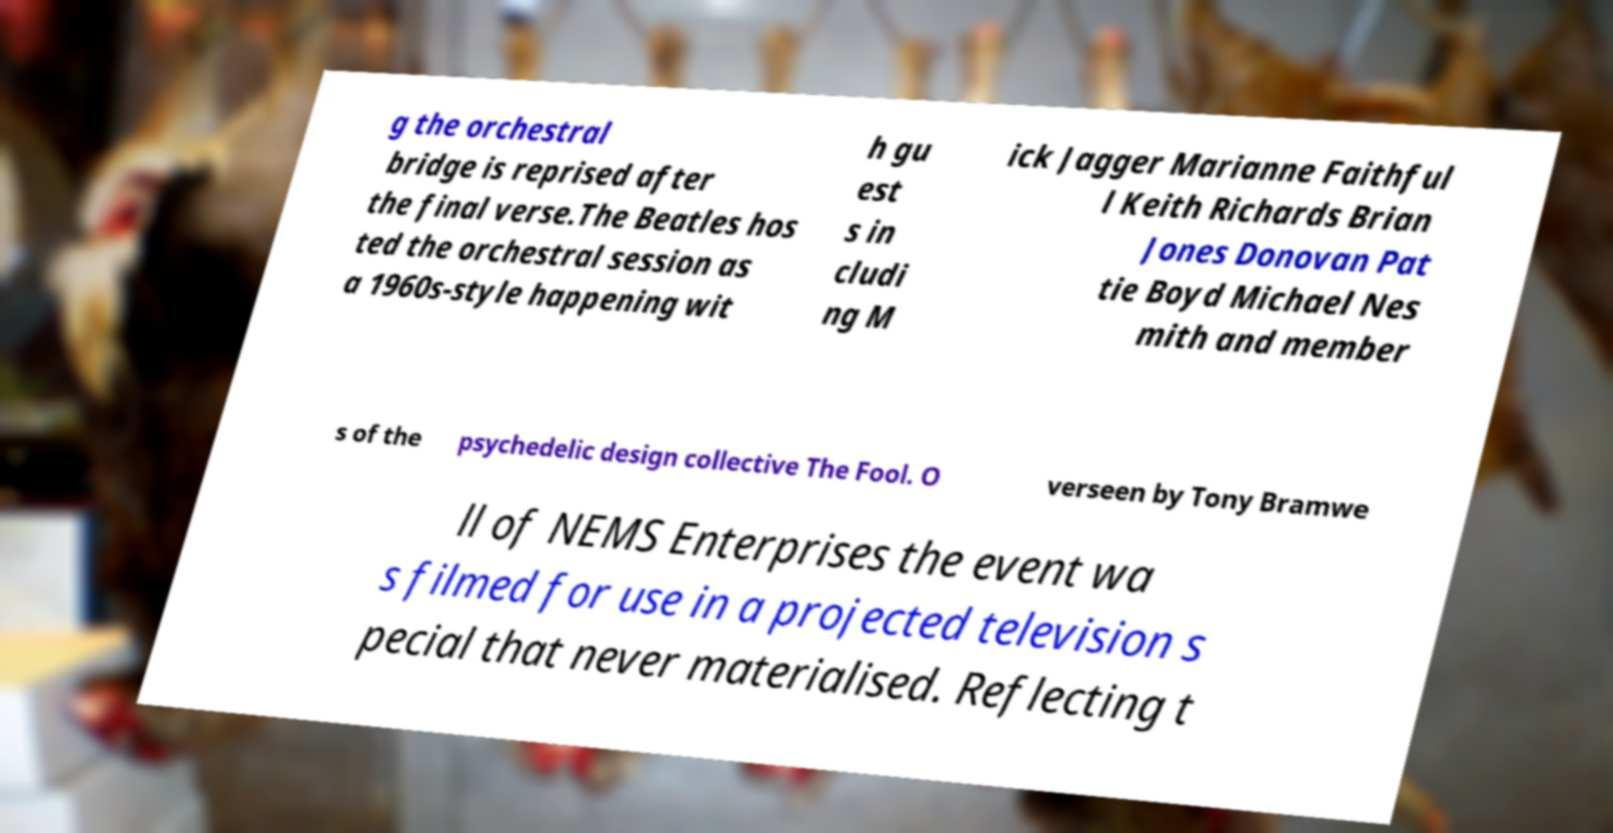Can you accurately transcribe the text from the provided image for me? g the orchestral bridge is reprised after the final verse.The Beatles hos ted the orchestral session as a 1960s-style happening wit h gu est s in cludi ng M ick Jagger Marianne Faithful l Keith Richards Brian Jones Donovan Pat tie Boyd Michael Nes mith and member s of the psychedelic design collective The Fool. O verseen by Tony Bramwe ll of NEMS Enterprises the event wa s filmed for use in a projected television s pecial that never materialised. Reflecting t 